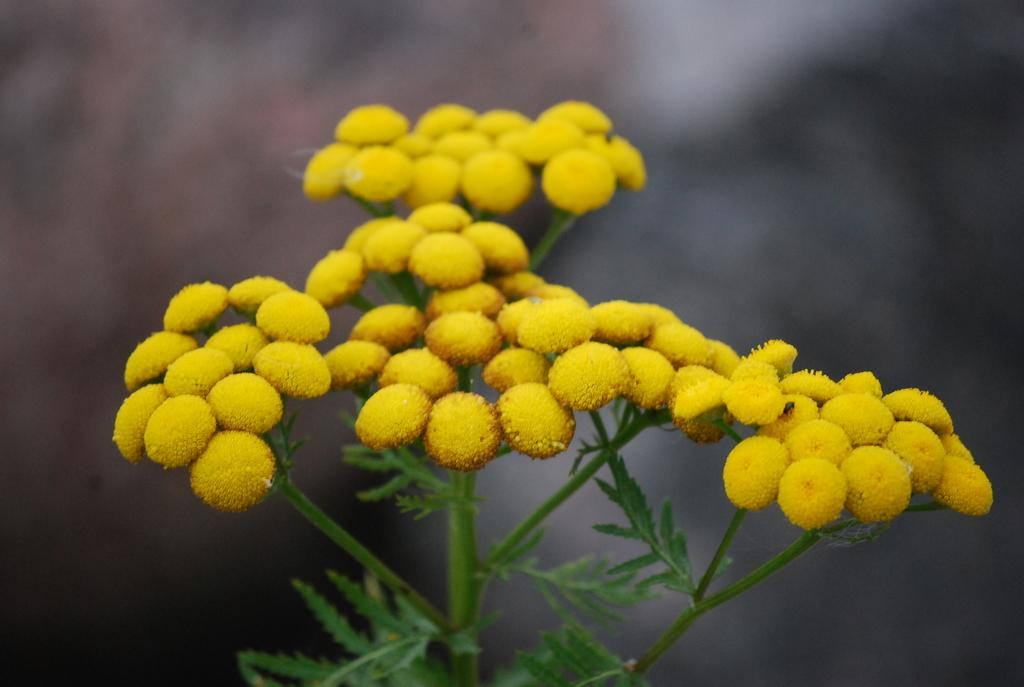What is the main subject of the image? The main subject of the image is a plant. What color are the flowers on the plant? The flowers on the plant are yellow. Can you describe the background of the image? The background of the image is blurred. What type of calendar is hanging on the wall in the image? There is no calendar present in the image; it only features a plant with yellow flowers against a blurred background. 